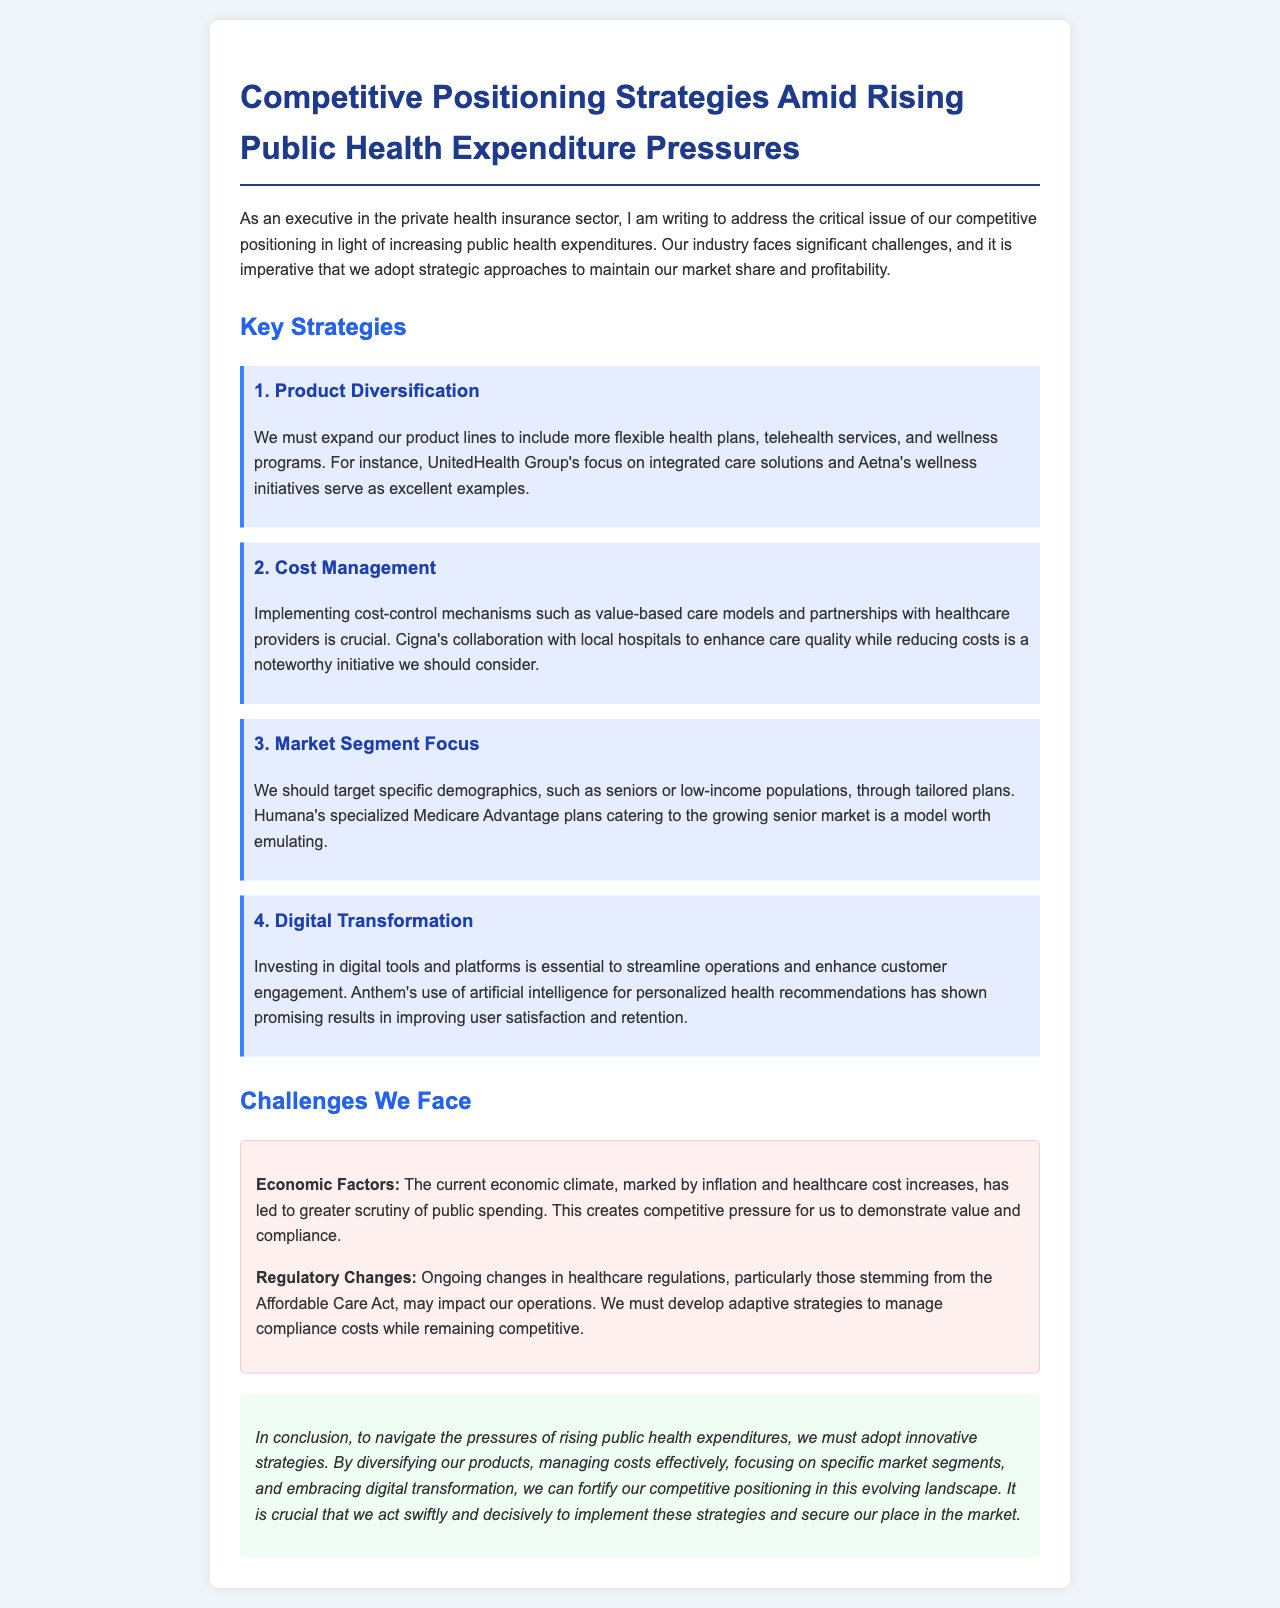What is the title of the document? The title of the document is mentioned at the beginning, encapsulating the main focus of the letter.
Answer: Competitive Positioning Strategies Amid Rising Public Health Expenditure Pressures What is the first strategy mentioned? The first strategy outlined in the letter is clearly stated under the Key Strategies section.
Answer: Product Diversification Which company is cited for its focus on integrated care solutions? The text provides a specific example of a company listed for its strategy in the product diversification strategy section.
Answer: UnitedHealth Group What economic factor is noted as a challenge? The document indicates specific challenges the industry faces, highlighting key economic influences.
Answer: Inflation What demographic target is suggested for focused market segments? The letter recommends targeting particular groups as part of the market segment strategy, which is explicitly stated.
Answer: Seniors How does Anthem enhance customer engagement? The document describes specific initiatives by companies to illustrate strategic approaches, including Anthem's use of technology.
Answer: Artificial intelligence What regulatory act is mentioned in the challenges section? The document refers to regulatory influences that may impact operations within the health insurance sector.
Answer: Affordable Care Act What is the purpose of the conclusion? The conclusion summarizes the strategies discussed throughout the document, emphasizing actionable steps for the company.
Answer: To navigate the pressures of rising public health expenditures How many strategies are outlined in total? The document presents a structured list of strategies, easily identifiable in the Key Strategies section.
Answer: Four 